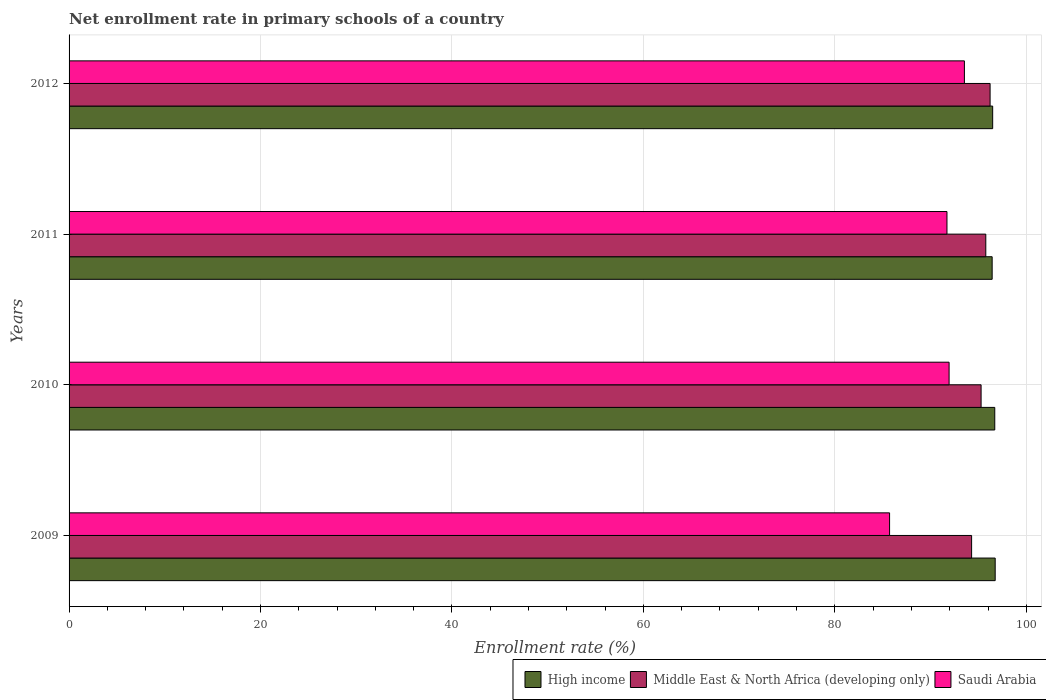How many groups of bars are there?
Your answer should be compact. 4. Are the number of bars on each tick of the Y-axis equal?
Offer a terse response. Yes. How many bars are there on the 2nd tick from the top?
Your answer should be very brief. 3. What is the enrollment rate in primary schools in Saudi Arabia in 2010?
Give a very brief answer. 91.94. Across all years, what is the maximum enrollment rate in primary schools in Saudi Arabia?
Keep it short and to the point. 93.54. Across all years, what is the minimum enrollment rate in primary schools in High income?
Ensure brevity in your answer.  96.43. In which year was the enrollment rate in primary schools in Saudi Arabia maximum?
Your response must be concise. 2012. What is the total enrollment rate in primary schools in Middle East & North Africa (developing only) in the graph?
Offer a terse response. 381.56. What is the difference between the enrollment rate in primary schools in High income in 2011 and that in 2012?
Your response must be concise. -0.05. What is the difference between the enrollment rate in primary schools in Middle East & North Africa (developing only) in 2009 and the enrollment rate in primary schools in Saudi Arabia in 2012?
Your answer should be compact. 0.75. What is the average enrollment rate in primary schools in High income per year?
Ensure brevity in your answer.  96.6. In the year 2009, what is the difference between the enrollment rate in primary schools in Middle East & North Africa (developing only) and enrollment rate in primary schools in Saudi Arabia?
Ensure brevity in your answer.  8.57. In how many years, is the enrollment rate in primary schools in Saudi Arabia greater than 84 %?
Ensure brevity in your answer.  4. What is the ratio of the enrollment rate in primary schools in Saudi Arabia in 2011 to that in 2012?
Provide a succinct answer. 0.98. Is the enrollment rate in primary schools in Middle East & North Africa (developing only) in 2010 less than that in 2011?
Provide a short and direct response. Yes. Is the difference between the enrollment rate in primary schools in Middle East & North Africa (developing only) in 2009 and 2012 greater than the difference between the enrollment rate in primary schools in Saudi Arabia in 2009 and 2012?
Keep it short and to the point. Yes. What is the difference between the highest and the second highest enrollment rate in primary schools in Middle East & North Africa (developing only)?
Keep it short and to the point. 0.45. What is the difference between the highest and the lowest enrollment rate in primary schools in Middle East & North Africa (developing only)?
Your response must be concise. 1.93. What does the 2nd bar from the top in 2011 represents?
Ensure brevity in your answer.  Middle East & North Africa (developing only). What does the 3rd bar from the bottom in 2011 represents?
Ensure brevity in your answer.  Saudi Arabia. Is it the case that in every year, the sum of the enrollment rate in primary schools in Middle East & North Africa (developing only) and enrollment rate in primary schools in High income is greater than the enrollment rate in primary schools in Saudi Arabia?
Give a very brief answer. Yes. How many bars are there?
Give a very brief answer. 12. Are all the bars in the graph horizontal?
Provide a short and direct response. Yes. What is the difference between two consecutive major ticks on the X-axis?
Keep it short and to the point. 20. Are the values on the major ticks of X-axis written in scientific E-notation?
Offer a very short reply. No. Where does the legend appear in the graph?
Give a very brief answer. Bottom right. How are the legend labels stacked?
Offer a terse response. Horizontal. What is the title of the graph?
Offer a very short reply. Net enrollment rate in primary schools of a country. What is the label or title of the X-axis?
Ensure brevity in your answer.  Enrollment rate (%). What is the Enrollment rate (%) of High income in 2009?
Make the answer very short. 96.75. What is the Enrollment rate (%) of Middle East & North Africa (developing only) in 2009?
Offer a terse response. 94.29. What is the Enrollment rate (%) in Saudi Arabia in 2009?
Ensure brevity in your answer.  85.72. What is the Enrollment rate (%) in High income in 2010?
Provide a short and direct response. 96.71. What is the Enrollment rate (%) of Middle East & North Africa (developing only) in 2010?
Make the answer very short. 95.28. What is the Enrollment rate (%) in Saudi Arabia in 2010?
Ensure brevity in your answer.  91.94. What is the Enrollment rate (%) of High income in 2011?
Provide a succinct answer. 96.43. What is the Enrollment rate (%) of Middle East & North Africa (developing only) in 2011?
Offer a terse response. 95.77. What is the Enrollment rate (%) of Saudi Arabia in 2011?
Offer a terse response. 91.71. What is the Enrollment rate (%) in High income in 2012?
Your response must be concise. 96.49. What is the Enrollment rate (%) in Middle East & North Africa (developing only) in 2012?
Make the answer very short. 96.22. What is the Enrollment rate (%) of Saudi Arabia in 2012?
Your answer should be very brief. 93.54. Across all years, what is the maximum Enrollment rate (%) of High income?
Your answer should be very brief. 96.75. Across all years, what is the maximum Enrollment rate (%) of Middle East & North Africa (developing only)?
Your response must be concise. 96.22. Across all years, what is the maximum Enrollment rate (%) in Saudi Arabia?
Your response must be concise. 93.54. Across all years, what is the minimum Enrollment rate (%) of High income?
Your response must be concise. 96.43. Across all years, what is the minimum Enrollment rate (%) of Middle East & North Africa (developing only)?
Your answer should be compact. 94.29. Across all years, what is the minimum Enrollment rate (%) in Saudi Arabia?
Your answer should be very brief. 85.72. What is the total Enrollment rate (%) in High income in the graph?
Your response must be concise. 386.38. What is the total Enrollment rate (%) of Middle East & North Africa (developing only) in the graph?
Make the answer very short. 381.56. What is the total Enrollment rate (%) of Saudi Arabia in the graph?
Your answer should be very brief. 362.9. What is the difference between the Enrollment rate (%) of High income in 2009 and that in 2010?
Your response must be concise. 0.04. What is the difference between the Enrollment rate (%) of Middle East & North Africa (developing only) in 2009 and that in 2010?
Provide a short and direct response. -0.99. What is the difference between the Enrollment rate (%) in Saudi Arabia in 2009 and that in 2010?
Provide a succinct answer. -6.22. What is the difference between the Enrollment rate (%) of High income in 2009 and that in 2011?
Offer a terse response. 0.32. What is the difference between the Enrollment rate (%) in Middle East & North Africa (developing only) in 2009 and that in 2011?
Make the answer very short. -1.48. What is the difference between the Enrollment rate (%) in Saudi Arabia in 2009 and that in 2011?
Ensure brevity in your answer.  -6. What is the difference between the Enrollment rate (%) of High income in 2009 and that in 2012?
Offer a very short reply. 0.26. What is the difference between the Enrollment rate (%) in Middle East & North Africa (developing only) in 2009 and that in 2012?
Your answer should be compact. -1.93. What is the difference between the Enrollment rate (%) in Saudi Arabia in 2009 and that in 2012?
Your response must be concise. -7.82. What is the difference between the Enrollment rate (%) of High income in 2010 and that in 2011?
Give a very brief answer. 0.27. What is the difference between the Enrollment rate (%) of Middle East & North Africa (developing only) in 2010 and that in 2011?
Make the answer very short. -0.49. What is the difference between the Enrollment rate (%) of Saudi Arabia in 2010 and that in 2011?
Your response must be concise. 0.22. What is the difference between the Enrollment rate (%) of High income in 2010 and that in 2012?
Your answer should be very brief. 0.22. What is the difference between the Enrollment rate (%) of Middle East & North Africa (developing only) in 2010 and that in 2012?
Your answer should be compact. -0.94. What is the difference between the Enrollment rate (%) in Saudi Arabia in 2010 and that in 2012?
Give a very brief answer. -1.6. What is the difference between the Enrollment rate (%) in High income in 2011 and that in 2012?
Give a very brief answer. -0.05. What is the difference between the Enrollment rate (%) in Middle East & North Africa (developing only) in 2011 and that in 2012?
Make the answer very short. -0.45. What is the difference between the Enrollment rate (%) of Saudi Arabia in 2011 and that in 2012?
Provide a succinct answer. -1.82. What is the difference between the Enrollment rate (%) in High income in 2009 and the Enrollment rate (%) in Middle East & North Africa (developing only) in 2010?
Keep it short and to the point. 1.47. What is the difference between the Enrollment rate (%) in High income in 2009 and the Enrollment rate (%) in Saudi Arabia in 2010?
Provide a succinct answer. 4.81. What is the difference between the Enrollment rate (%) of Middle East & North Africa (developing only) in 2009 and the Enrollment rate (%) of Saudi Arabia in 2010?
Your response must be concise. 2.35. What is the difference between the Enrollment rate (%) in High income in 2009 and the Enrollment rate (%) in Middle East & North Africa (developing only) in 2011?
Make the answer very short. 0.98. What is the difference between the Enrollment rate (%) in High income in 2009 and the Enrollment rate (%) in Saudi Arabia in 2011?
Keep it short and to the point. 5.04. What is the difference between the Enrollment rate (%) of Middle East & North Africa (developing only) in 2009 and the Enrollment rate (%) of Saudi Arabia in 2011?
Provide a succinct answer. 2.57. What is the difference between the Enrollment rate (%) in High income in 2009 and the Enrollment rate (%) in Middle East & North Africa (developing only) in 2012?
Give a very brief answer. 0.53. What is the difference between the Enrollment rate (%) in High income in 2009 and the Enrollment rate (%) in Saudi Arabia in 2012?
Your response must be concise. 3.22. What is the difference between the Enrollment rate (%) in Middle East & North Africa (developing only) in 2009 and the Enrollment rate (%) in Saudi Arabia in 2012?
Provide a succinct answer. 0.75. What is the difference between the Enrollment rate (%) of High income in 2010 and the Enrollment rate (%) of Middle East & North Africa (developing only) in 2011?
Your answer should be compact. 0.94. What is the difference between the Enrollment rate (%) of High income in 2010 and the Enrollment rate (%) of Saudi Arabia in 2011?
Provide a succinct answer. 4.99. What is the difference between the Enrollment rate (%) in Middle East & North Africa (developing only) in 2010 and the Enrollment rate (%) in Saudi Arabia in 2011?
Make the answer very short. 3.56. What is the difference between the Enrollment rate (%) of High income in 2010 and the Enrollment rate (%) of Middle East & North Africa (developing only) in 2012?
Offer a very short reply. 0.49. What is the difference between the Enrollment rate (%) of High income in 2010 and the Enrollment rate (%) of Saudi Arabia in 2012?
Provide a short and direct response. 3.17. What is the difference between the Enrollment rate (%) of Middle East & North Africa (developing only) in 2010 and the Enrollment rate (%) of Saudi Arabia in 2012?
Your answer should be very brief. 1.74. What is the difference between the Enrollment rate (%) in High income in 2011 and the Enrollment rate (%) in Middle East & North Africa (developing only) in 2012?
Offer a very short reply. 0.22. What is the difference between the Enrollment rate (%) of High income in 2011 and the Enrollment rate (%) of Saudi Arabia in 2012?
Provide a succinct answer. 2.9. What is the difference between the Enrollment rate (%) in Middle East & North Africa (developing only) in 2011 and the Enrollment rate (%) in Saudi Arabia in 2012?
Your answer should be very brief. 2.23. What is the average Enrollment rate (%) in High income per year?
Ensure brevity in your answer.  96.6. What is the average Enrollment rate (%) in Middle East & North Africa (developing only) per year?
Your answer should be very brief. 95.39. What is the average Enrollment rate (%) of Saudi Arabia per year?
Give a very brief answer. 90.73. In the year 2009, what is the difference between the Enrollment rate (%) of High income and Enrollment rate (%) of Middle East & North Africa (developing only)?
Offer a very short reply. 2.46. In the year 2009, what is the difference between the Enrollment rate (%) in High income and Enrollment rate (%) in Saudi Arabia?
Provide a short and direct response. 11.03. In the year 2009, what is the difference between the Enrollment rate (%) in Middle East & North Africa (developing only) and Enrollment rate (%) in Saudi Arabia?
Give a very brief answer. 8.57. In the year 2010, what is the difference between the Enrollment rate (%) in High income and Enrollment rate (%) in Middle East & North Africa (developing only)?
Your response must be concise. 1.43. In the year 2010, what is the difference between the Enrollment rate (%) in High income and Enrollment rate (%) in Saudi Arabia?
Provide a short and direct response. 4.77. In the year 2010, what is the difference between the Enrollment rate (%) in Middle East & North Africa (developing only) and Enrollment rate (%) in Saudi Arabia?
Your answer should be compact. 3.34. In the year 2011, what is the difference between the Enrollment rate (%) in High income and Enrollment rate (%) in Middle East & North Africa (developing only)?
Give a very brief answer. 0.66. In the year 2011, what is the difference between the Enrollment rate (%) of High income and Enrollment rate (%) of Saudi Arabia?
Your answer should be very brief. 4.72. In the year 2011, what is the difference between the Enrollment rate (%) in Middle East & North Africa (developing only) and Enrollment rate (%) in Saudi Arabia?
Offer a terse response. 4.06. In the year 2012, what is the difference between the Enrollment rate (%) in High income and Enrollment rate (%) in Middle East & North Africa (developing only)?
Your response must be concise. 0.27. In the year 2012, what is the difference between the Enrollment rate (%) of High income and Enrollment rate (%) of Saudi Arabia?
Your response must be concise. 2.95. In the year 2012, what is the difference between the Enrollment rate (%) in Middle East & North Africa (developing only) and Enrollment rate (%) in Saudi Arabia?
Your response must be concise. 2.68. What is the ratio of the Enrollment rate (%) of High income in 2009 to that in 2010?
Provide a short and direct response. 1. What is the ratio of the Enrollment rate (%) in Middle East & North Africa (developing only) in 2009 to that in 2010?
Make the answer very short. 0.99. What is the ratio of the Enrollment rate (%) of Saudi Arabia in 2009 to that in 2010?
Your answer should be very brief. 0.93. What is the ratio of the Enrollment rate (%) of Middle East & North Africa (developing only) in 2009 to that in 2011?
Provide a succinct answer. 0.98. What is the ratio of the Enrollment rate (%) of Saudi Arabia in 2009 to that in 2011?
Offer a very short reply. 0.93. What is the ratio of the Enrollment rate (%) of High income in 2009 to that in 2012?
Offer a terse response. 1. What is the ratio of the Enrollment rate (%) in Middle East & North Africa (developing only) in 2009 to that in 2012?
Keep it short and to the point. 0.98. What is the ratio of the Enrollment rate (%) of Saudi Arabia in 2009 to that in 2012?
Ensure brevity in your answer.  0.92. What is the ratio of the Enrollment rate (%) of High income in 2010 to that in 2011?
Make the answer very short. 1. What is the ratio of the Enrollment rate (%) of Middle East & North Africa (developing only) in 2010 to that in 2011?
Offer a terse response. 0.99. What is the ratio of the Enrollment rate (%) of Middle East & North Africa (developing only) in 2010 to that in 2012?
Provide a succinct answer. 0.99. What is the ratio of the Enrollment rate (%) of Saudi Arabia in 2010 to that in 2012?
Offer a very short reply. 0.98. What is the ratio of the Enrollment rate (%) in Saudi Arabia in 2011 to that in 2012?
Your response must be concise. 0.98. What is the difference between the highest and the second highest Enrollment rate (%) in High income?
Give a very brief answer. 0.04. What is the difference between the highest and the second highest Enrollment rate (%) of Middle East & North Africa (developing only)?
Offer a very short reply. 0.45. What is the difference between the highest and the second highest Enrollment rate (%) of Saudi Arabia?
Your response must be concise. 1.6. What is the difference between the highest and the lowest Enrollment rate (%) in High income?
Offer a terse response. 0.32. What is the difference between the highest and the lowest Enrollment rate (%) in Middle East & North Africa (developing only)?
Your answer should be compact. 1.93. What is the difference between the highest and the lowest Enrollment rate (%) of Saudi Arabia?
Provide a short and direct response. 7.82. 